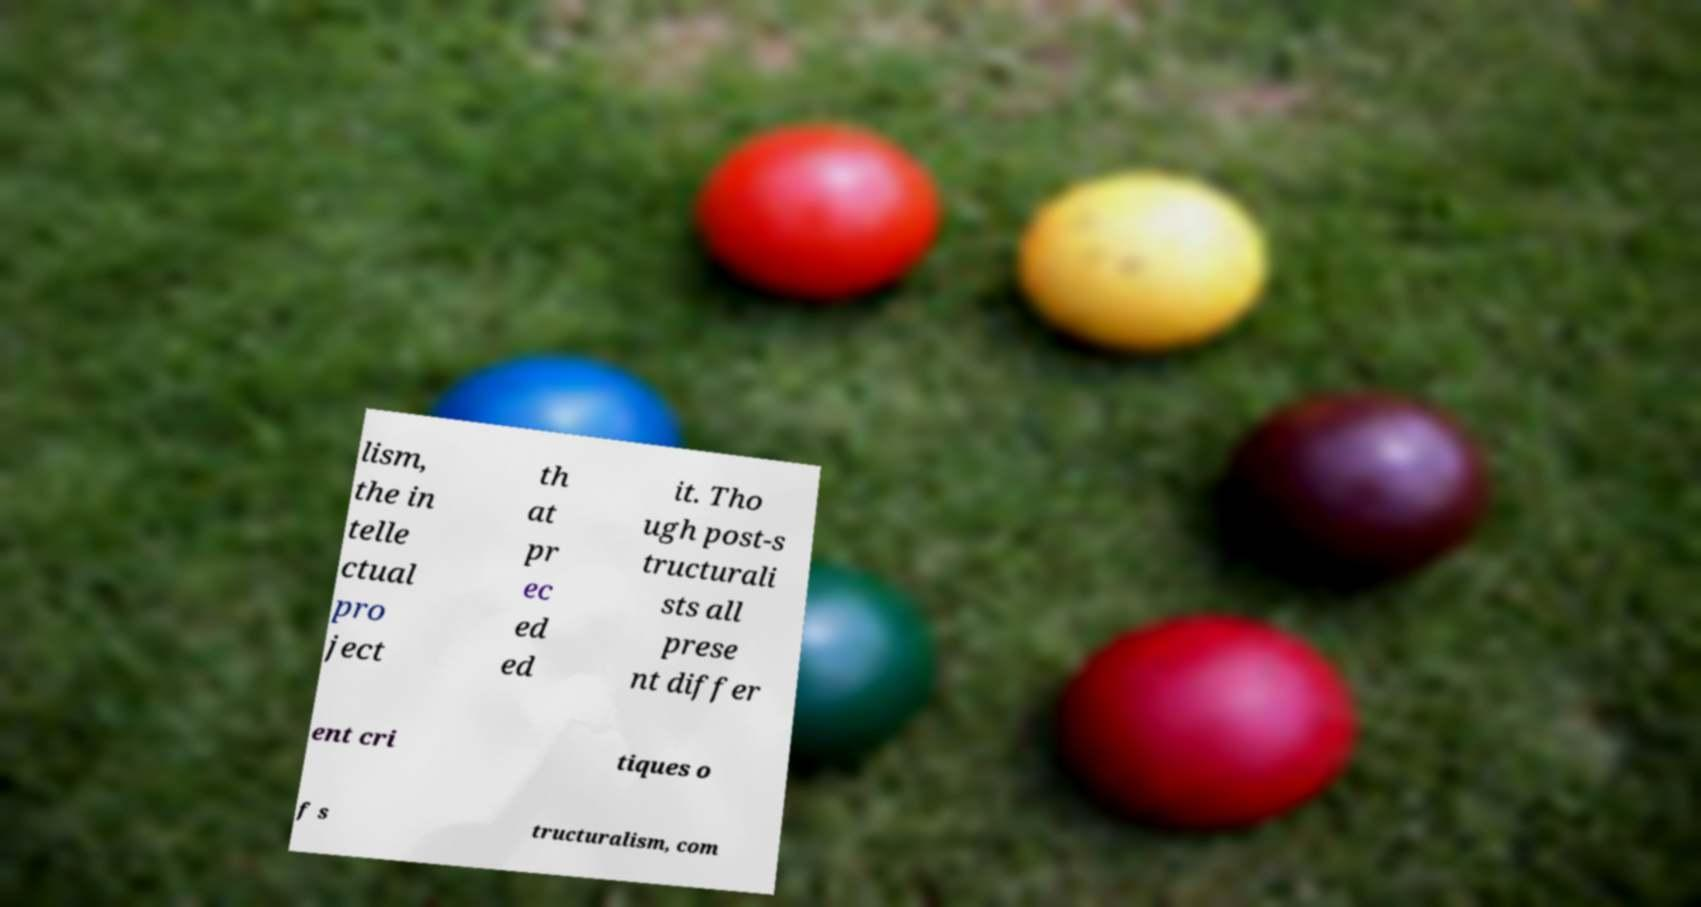Please identify and transcribe the text found in this image. lism, the in telle ctual pro ject th at pr ec ed ed it. Tho ugh post-s tructurali sts all prese nt differ ent cri tiques o f s tructuralism, com 